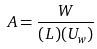<formula> <loc_0><loc_0><loc_500><loc_500>A = \frac { W } { ( L ) ( U _ { w } ) }</formula> 